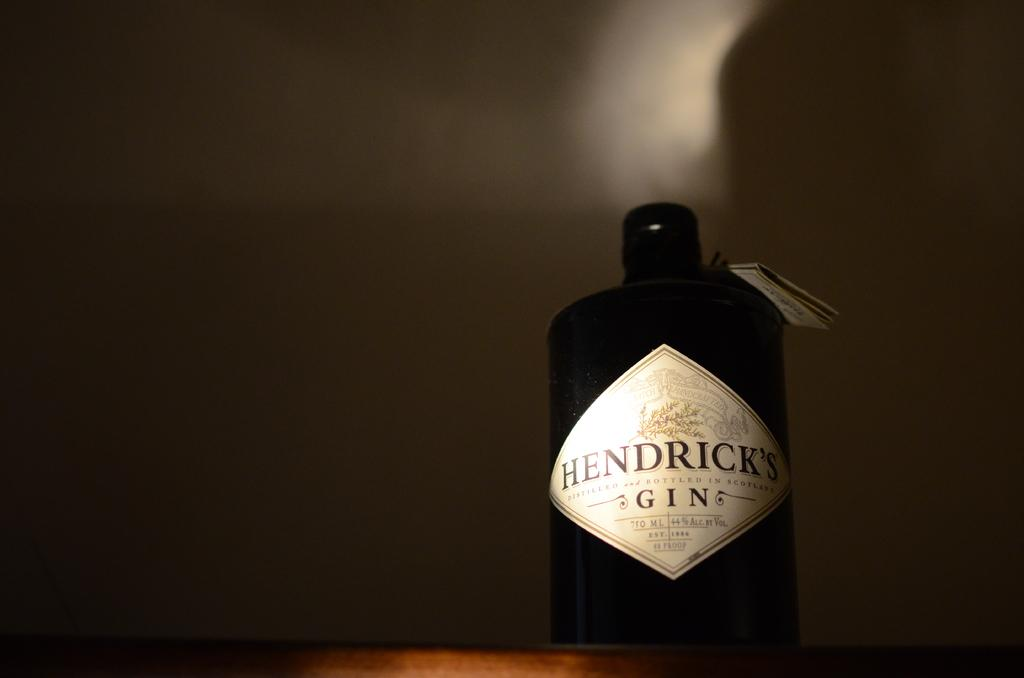<image>
Describe the image concisely. A bottle of Hendricks Gin is seen sitting on a table against a shadowy backdrop. 